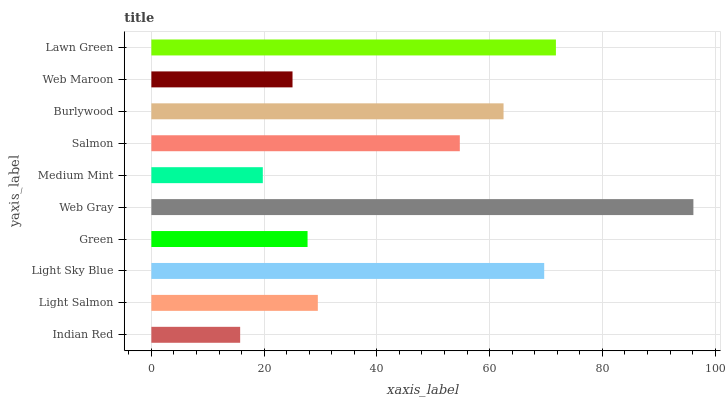Is Indian Red the minimum?
Answer yes or no. Yes. Is Web Gray the maximum?
Answer yes or no. Yes. Is Light Salmon the minimum?
Answer yes or no. No. Is Light Salmon the maximum?
Answer yes or no. No. Is Light Salmon greater than Indian Red?
Answer yes or no. Yes. Is Indian Red less than Light Salmon?
Answer yes or no. Yes. Is Indian Red greater than Light Salmon?
Answer yes or no. No. Is Light Salmon less than Indian Red?
Answer yes or no. No. Is Salmon the high median?
Answer yes or no. Yes. Is Light Salmon the low median?
Answer yes or no. Yes. Is Medium Mint the high median?
Answer yes or no. No. Is Web Gray the low median?
Answer yes or no. No. 